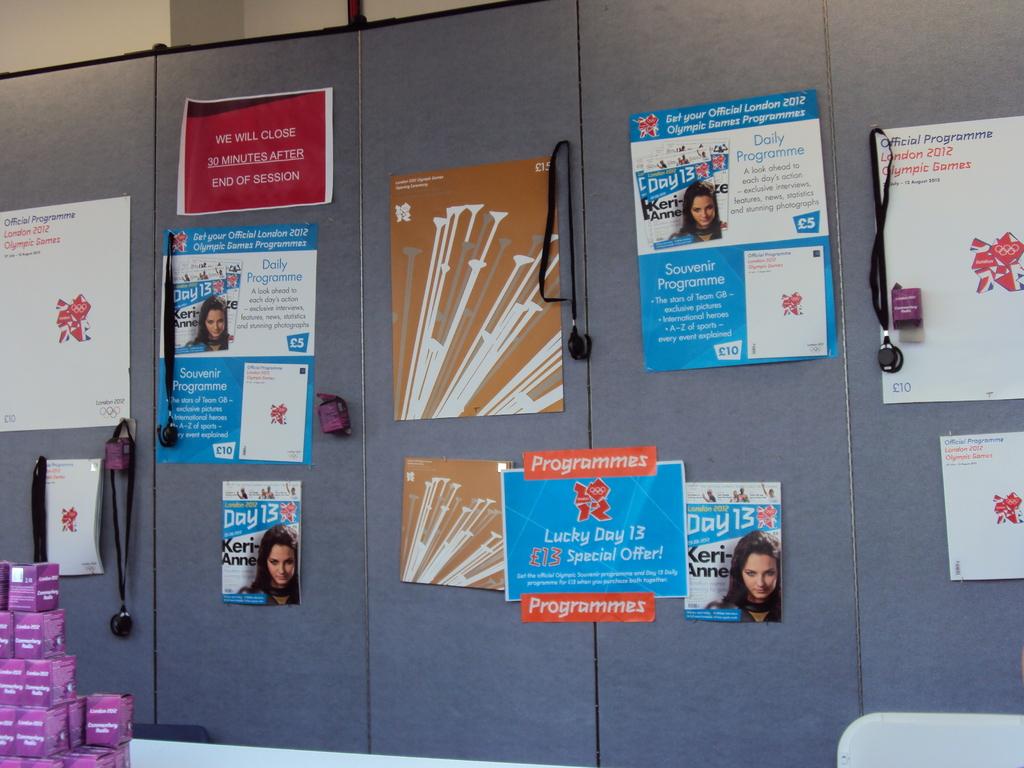What day is it showing on the posters?
Make the answer very short. 13. 